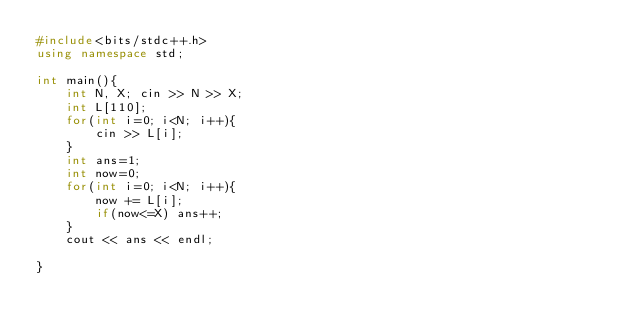Convert code to text. <code><loc_0><loc_0><loc_500><loc_500><_C++_>#include<bits/stdc++.h>
using namespace std;

int main(){
    int N, X; cin >> N >> X;
    int L[110];
    for(int i=0; i<N; i++){
        cin >> L[i];
    }
    int ans=1;
    int now=0;
    for(int i=0; i<N; i++){
        now += L[i];
        if(now<=X) ans++;
    }
    cout << ans << endl;

}</code> 